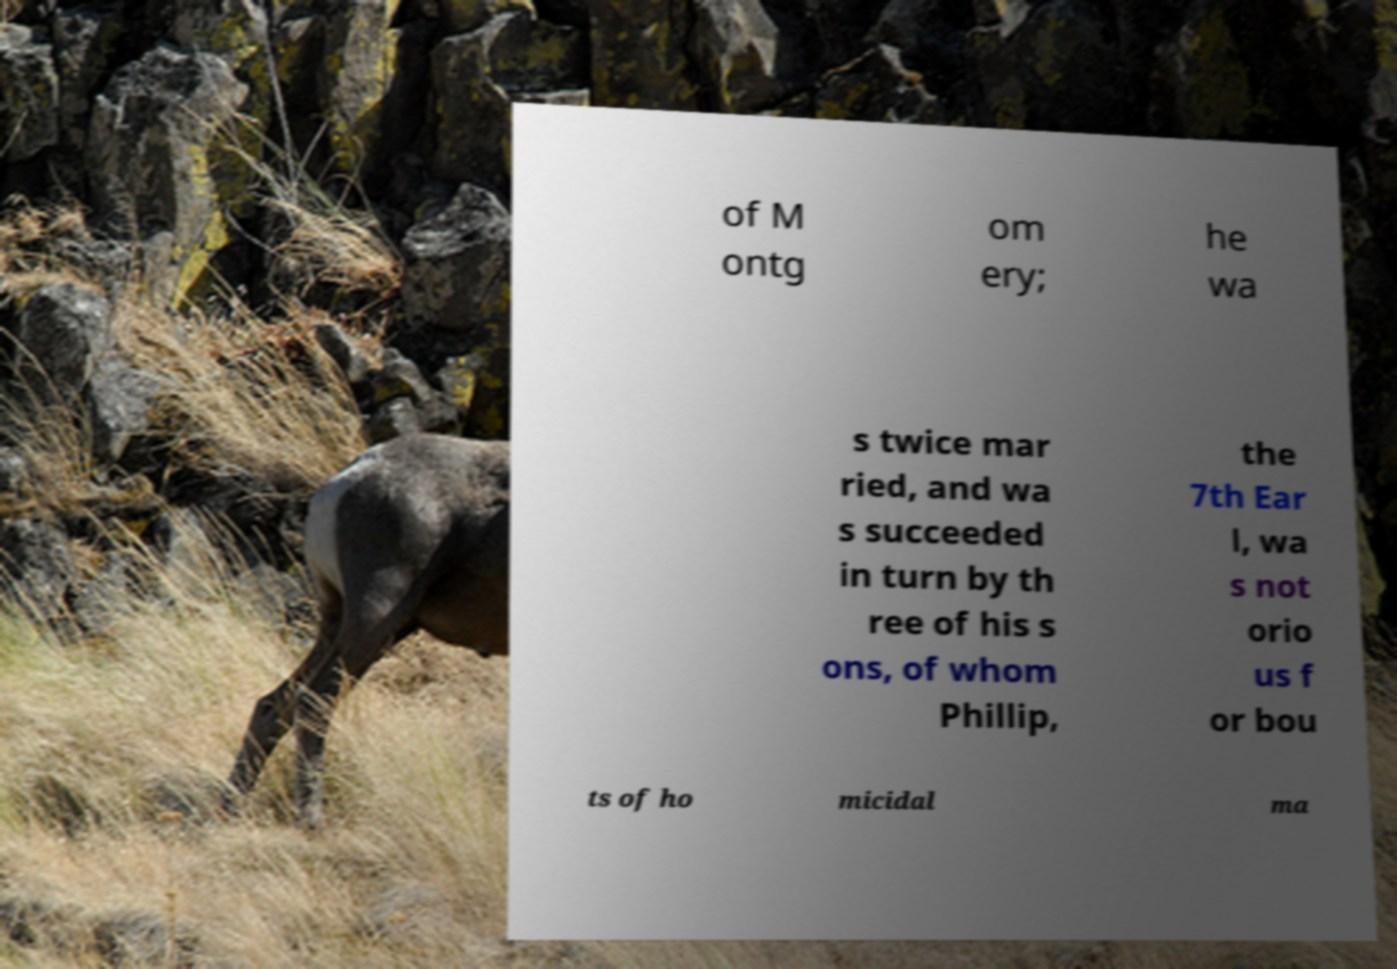Please read and relay the text visible in this image. What does it say? of M ontg om ery; he wa s twice mar ried, and wa s succeeded in turn by th ree of his s ons, of whom Phillip, the 7th Ear l, wa s not orio us f or bou ts of ho micidal ma 